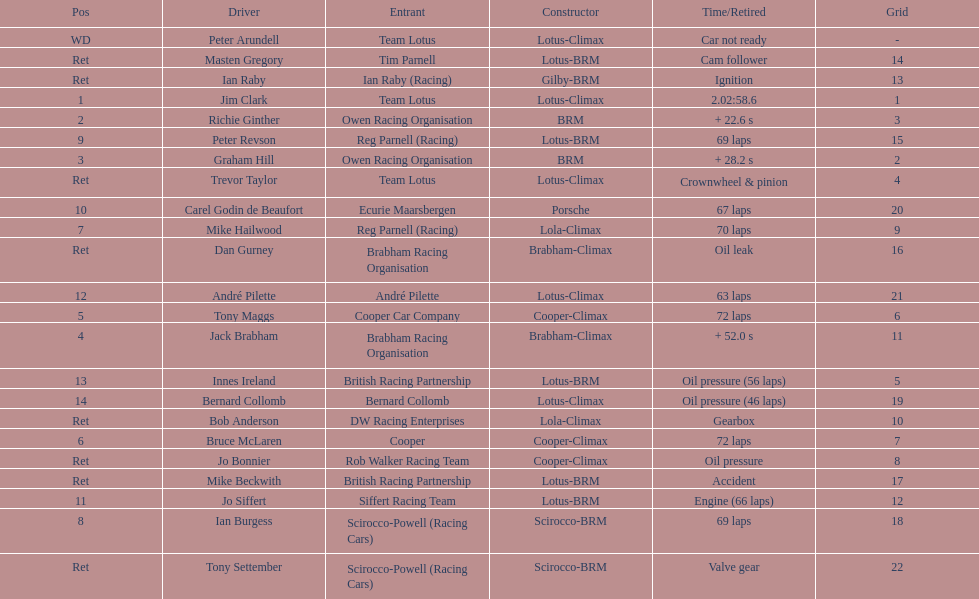What was the same problem that bernard collomb had as innes ireland? Oil pressure. 